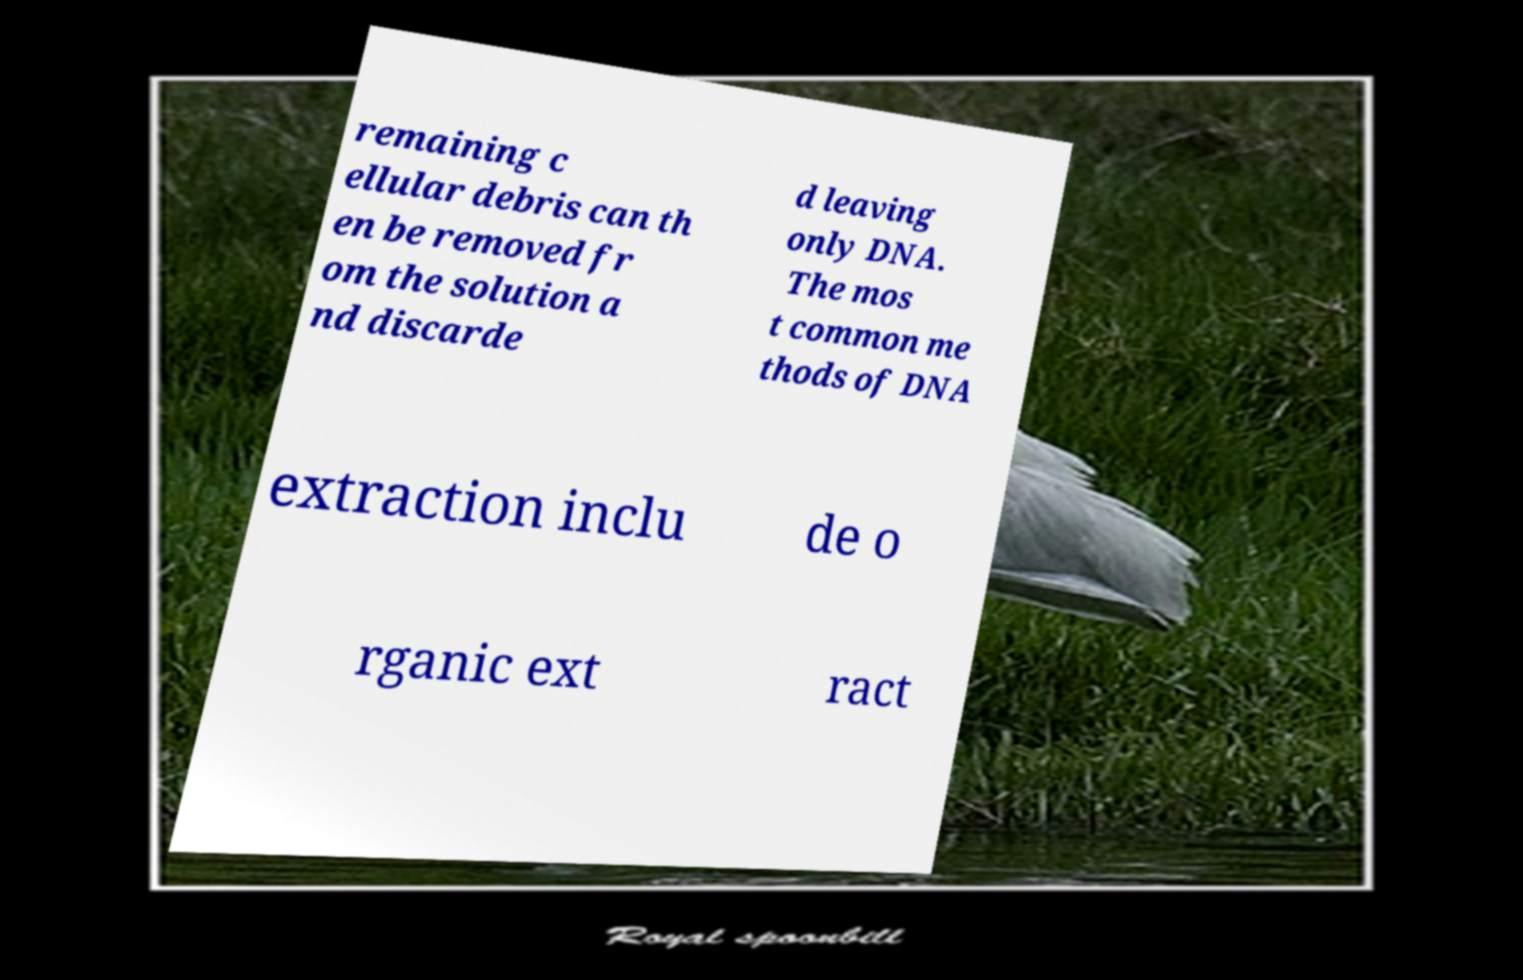I need the written content from this picture converted into text. Can you do that? remaining c ellular debris can th en be removed fr om the solution a nd discarde d leaving only DNA. The mos t common me thods of DNA extraction inclu de o rganic ext ract 